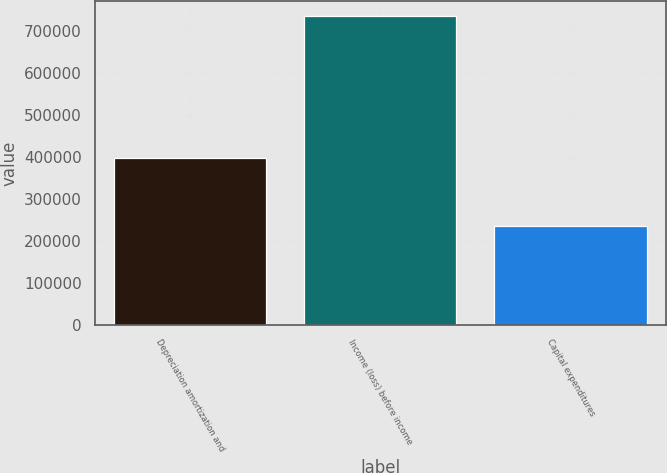<chart> <loc_0><loc_0><loc_500><loc_500><bar_chart><fcel>Depreciation amortization and<fcel>Income (loss) before income<fcel>Capital expenditures<nl><fcel>395974<fcel>734186<fcel>235625<nl></chart> 